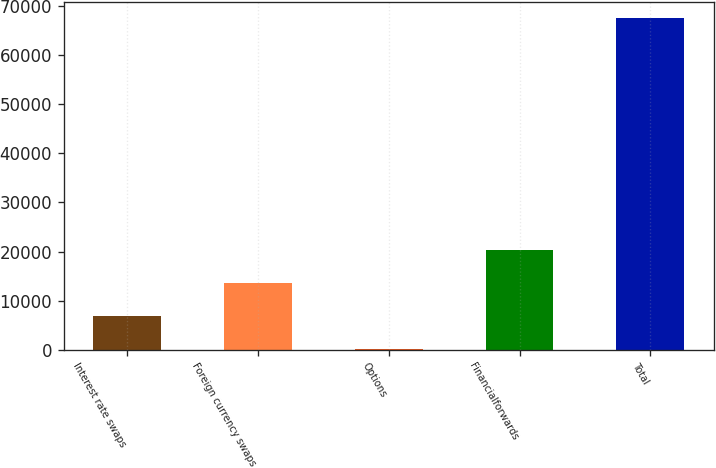<chart> <loc_0><loc_0><loc_500><loc_500><bar_chart><fcel>Interest rate swaps<fcel>Foreign currency swaps<fcel>Options<fcel>Financialforwards<fcel>Total<nl><fcel>6867.9<fcel>13607.8<fcel>128<fcel>20347.7<fcel>67527<nl></chart> 